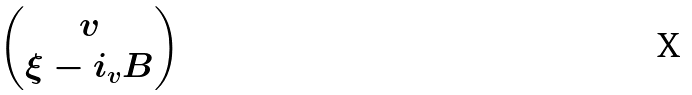Convert formula to latex. <formula><loc_0><loc_0><loc_500><loc_500>\begin{pmatrix} v \\ \xi - i _ { v } B \end{pmatrix}</formula> 